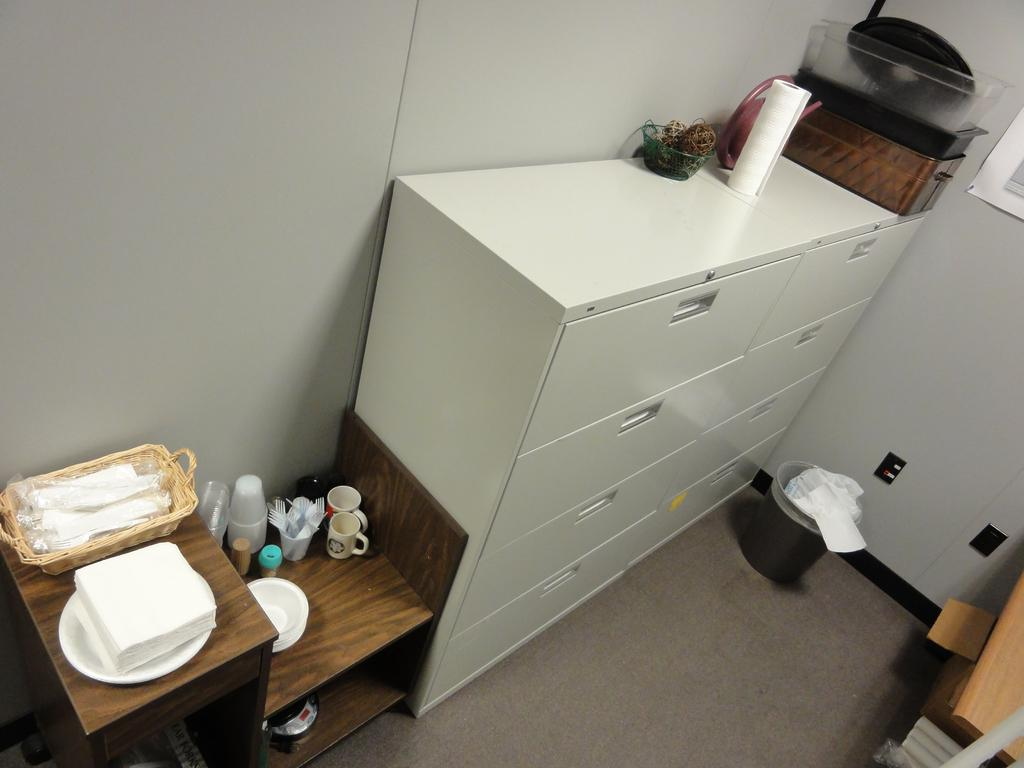What is the main object in the middle of the image? There is a wardrobe in the middle of the image. What is placed on top of the wardrobe? There is a bowl on the wardrobe. What object is also located in the middle of the image? There is a dustbin in the middle of the image. What is on the left side of the image? There is a table on the left side of the image. What items can be found on the table? There are tissues, a cup, and a glass on the table. What is the value of the snow on the wrist in the image? There is no snow or wrist present in the image, so it is not possible to determine the value of any snow on a wrist. 